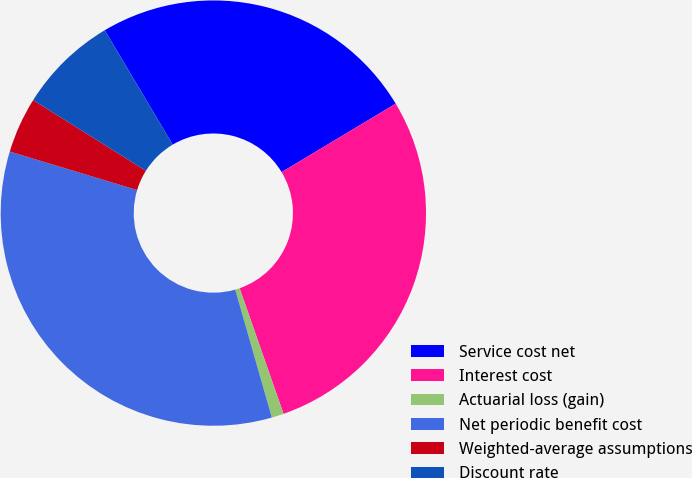Convert chart to OTSL. <chart><loc_0><loc_0><loc_500><loc_500><pie_chart><fcel>Service cost net<fcel>Interest cost<fcel>Actuarial loss (gain)<fcel>Net periodic benefit cost<fcel>Weighted-average assumptions<fcel>Discount rate<nl><fcel>24.93%<fcel>28.25%<fcel>0.92%<fcel>34.11%<fcel>4.24%<fcel>7.56%<nl></chart> 